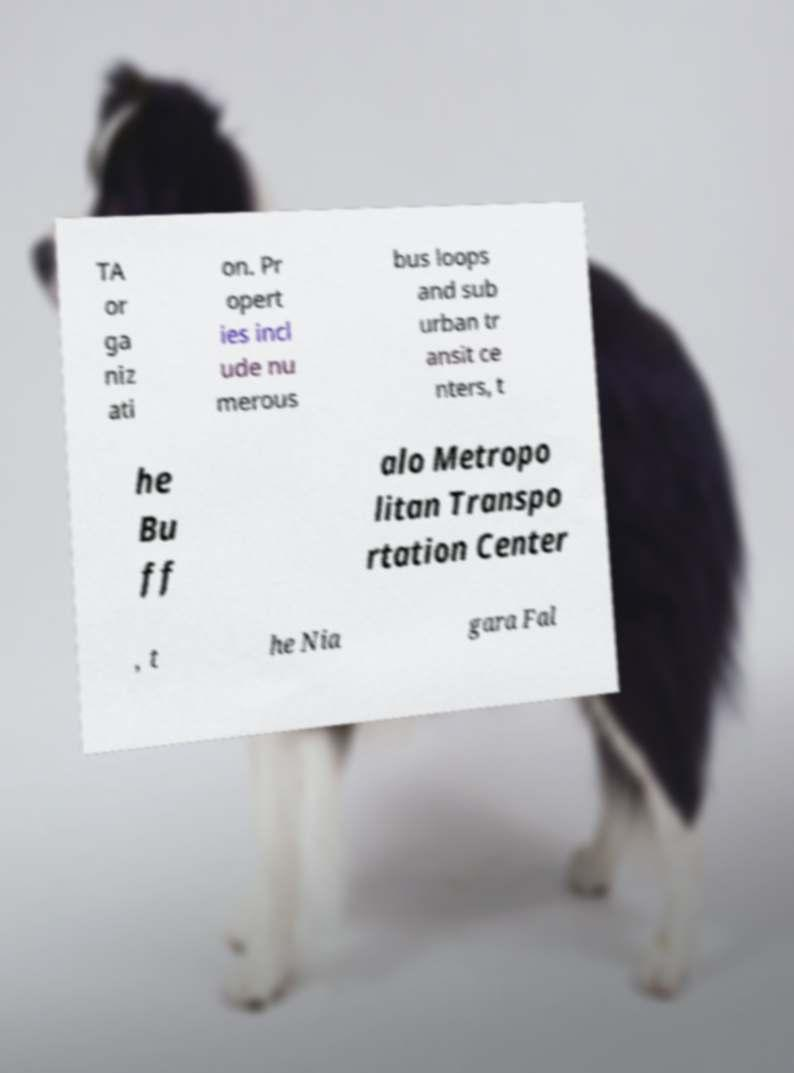What messages or text are displayed in this image? I need them in a readable, typed format. TA or ga niz ati on. Pr opert ies incl ude nu merous bus loops and sub urban tr ansit ce nters, t he Bu ff alo Metropo litan Transpo rtation Center , t he Nia gara Fal 